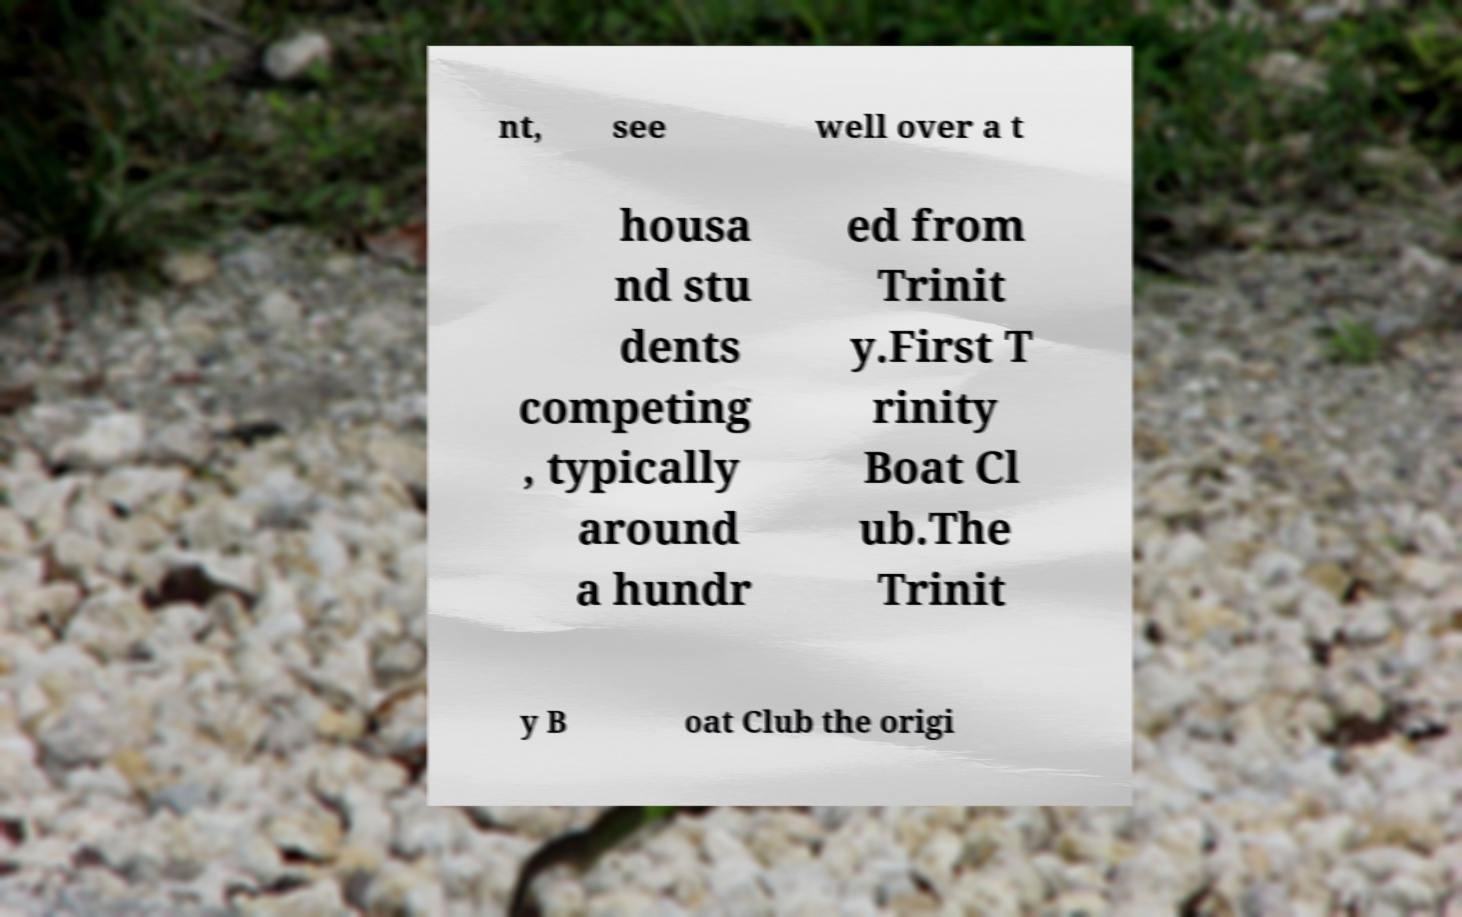Please identify and transcribe the text found in this image. nt, see well over a t housa nd stu dents competing , typically around a hundr ed from Trinit y.First T rinity Boat Cl ub.The Trinit y B oat Club the origi 